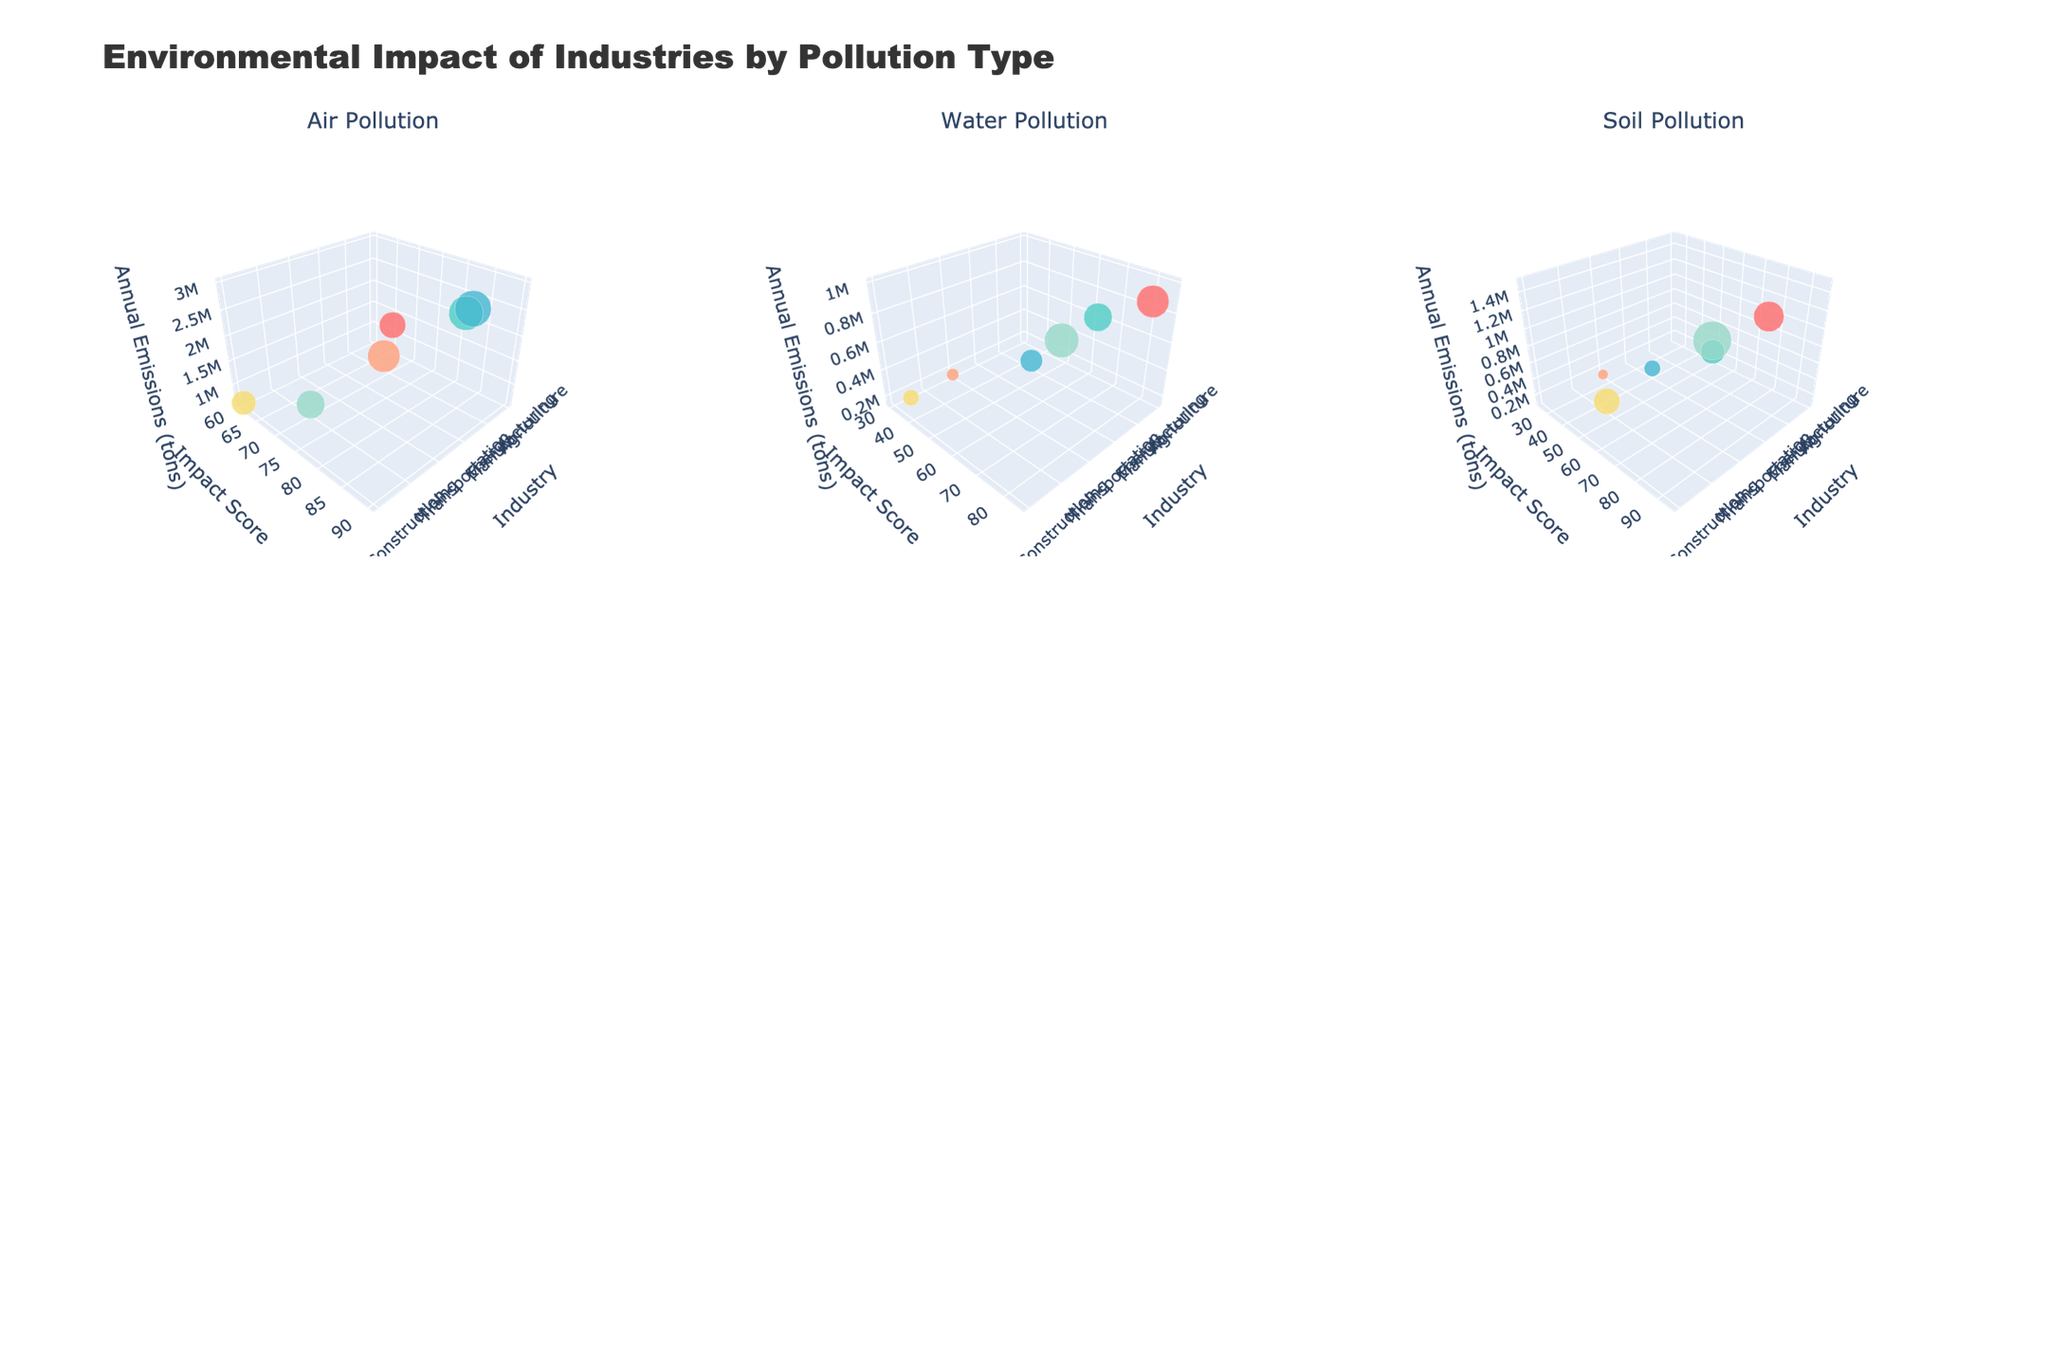What is the title of the plot? The title of the plot is displayed prominently at the top of the figure. It reads, "Environmental Impact of Industries by Pollution Type."
Answer: Environmental Impact of Industries by Pollution Type Which industry has the highest air pollution impact score? By looking at the subplot titled "Air Pollution," the bubble with the highest position on the y-axis (Impact Score) belongs to the Energy industry with an impact score of 90.
Answer: Energy How does the annual emissions of water pollution in mining compare to that in agriculture? In the subplot titled "Water Pollution," Mining is represented by a bubble at 1,000,000 tons, while Agriculture is at 850,000 tons. Mining's annual emissions are higher by 150,000 tons.
Answer: Mining is higher Which industry has the lowest soil pollution impact score and what is its annual emission? Checking the "Soil Pollution" subplot, the industry with the lowest impact score (y-axis) is Transportation with a score of 25. The corresponding annual emissions (z-axis) for Transportation are 100,000 tons.
Answer: Transportation, 100,000 tons What are the axis titles for the Air Pollution subplot? Each 3D subplot has three axes: x-axis for Industry, y-axis for Impact Score, and z-axis for Annual Emissions (tons). The titles are consistent across all subplots.
Answer: Industry, Impact Score, Annual Emissions (tons) Compare the impact scores of manufacturing across all types of pollution. In the "Air Pollution" subplot, the impact score for Manufacturing is 85. In "Water Pollution," it's 70. In "Soil Pollution," it's 60. Manufacturing has the highest impact score in Air Pollution, followed by Water, then Soil.
Answer: Air: 85, Water: 70, Soil: 60 Which pollution type has the highest average impact score and how is it calculated? First, compute the average impact score for each pollution type: Air ((65+85+90+80+70+60)/6 = 75), Water ((80+70+55+30+85+40)/6 = 60), and Soil ((75+60+40+25+95+65)/6 ≈ 60.83). Soil has the highest average impact score.
Answer: Soil, ≈ 60.83 What is the color scale used in the plot? The bubbles are colored using a custom scale consisting of pinkish-red, cyan, sky-blue, salmon, light green, and yellow colors to distinguish between industries.
Answer: Pinkish-red, Cyan, Sky-blue, Salmon, Light green, Yellow Does the subplot for soil pollution indicate any industry with both high impact score and high annual emissions? In "Soil Pollution," the Mining industry shows the highest impact score of 95 and the highest annual emissions of 1,500,000 tons. This indicates high scores in both dimensions.
Answer: Mining Which two industries have the closest annual emissions for air pollution, and what are those values? By referring to the "Air Pollution" subplot, Agriculture (1,200,000 tons) and Mining (800,000 tons) have the closest annual emissions values, differing by 400,000 tons.
Answer: Agriculture: 1,200,000 tons, Mining: 800,000 tons 